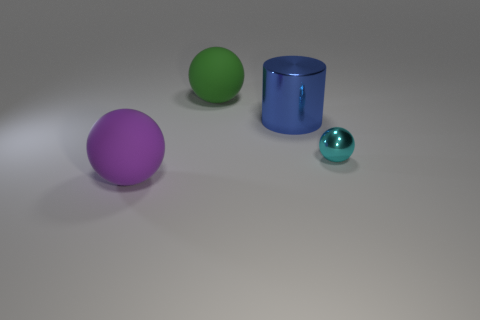How would you contrast the textures of the objects, based on their appearances? The objects in the image all appear to have smooth textures, particularly noticeable on the larger purple and green spheres and the blue cylinder. However, they may differ in material finish; the cylinder seems to have a more reflective surface compared to the matte finish of the spheres. 